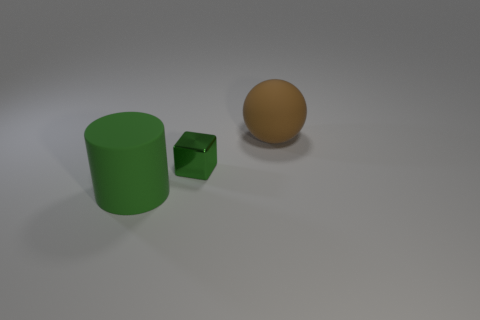Add 1 brown objects. How many objects exist? 4 Subtract all cylinders. How many objects are left? 2 Add 1 green metallic blocks. How many green metallic blocks are left? 2 Add 3 gray rubber balls. How many gray rubber balls exist? 3 Subtract 0 blue blocks. How many objects are left? 3 Subtract all big brown objects. Subtract all big gray shiny cylinders. How many objects are left? 2 